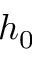Convert formula to latex. <formula><loc_0><loc_0><loc_500><loc_500>h _ { 0 }</formula> 